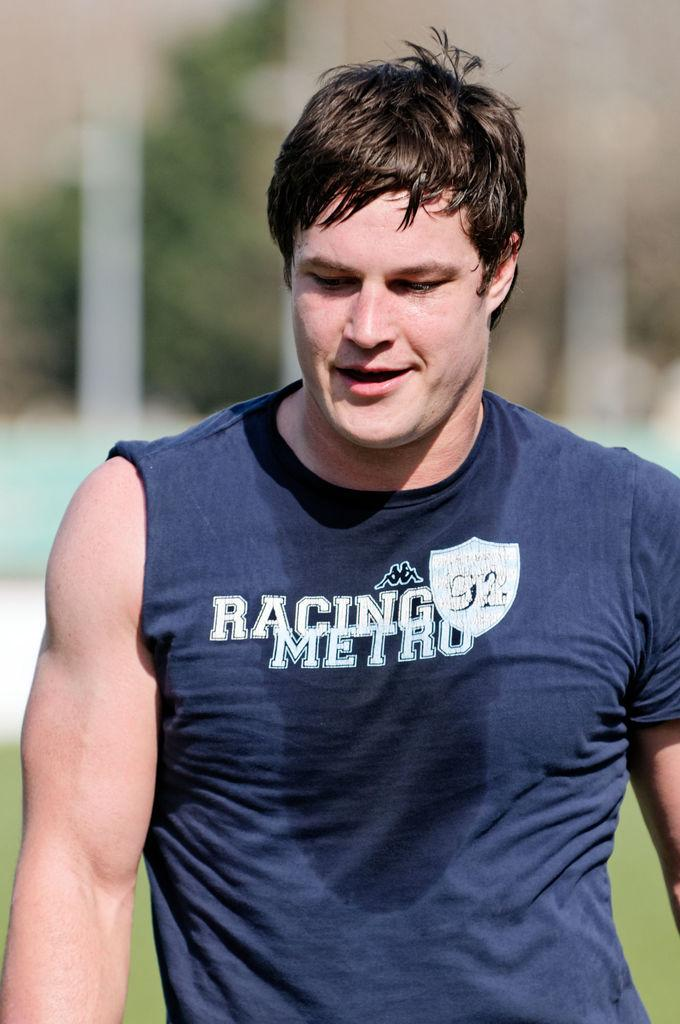<image>
Offer a succinct explanation of the picture presented. The male wears a top saying Racing Metro. 